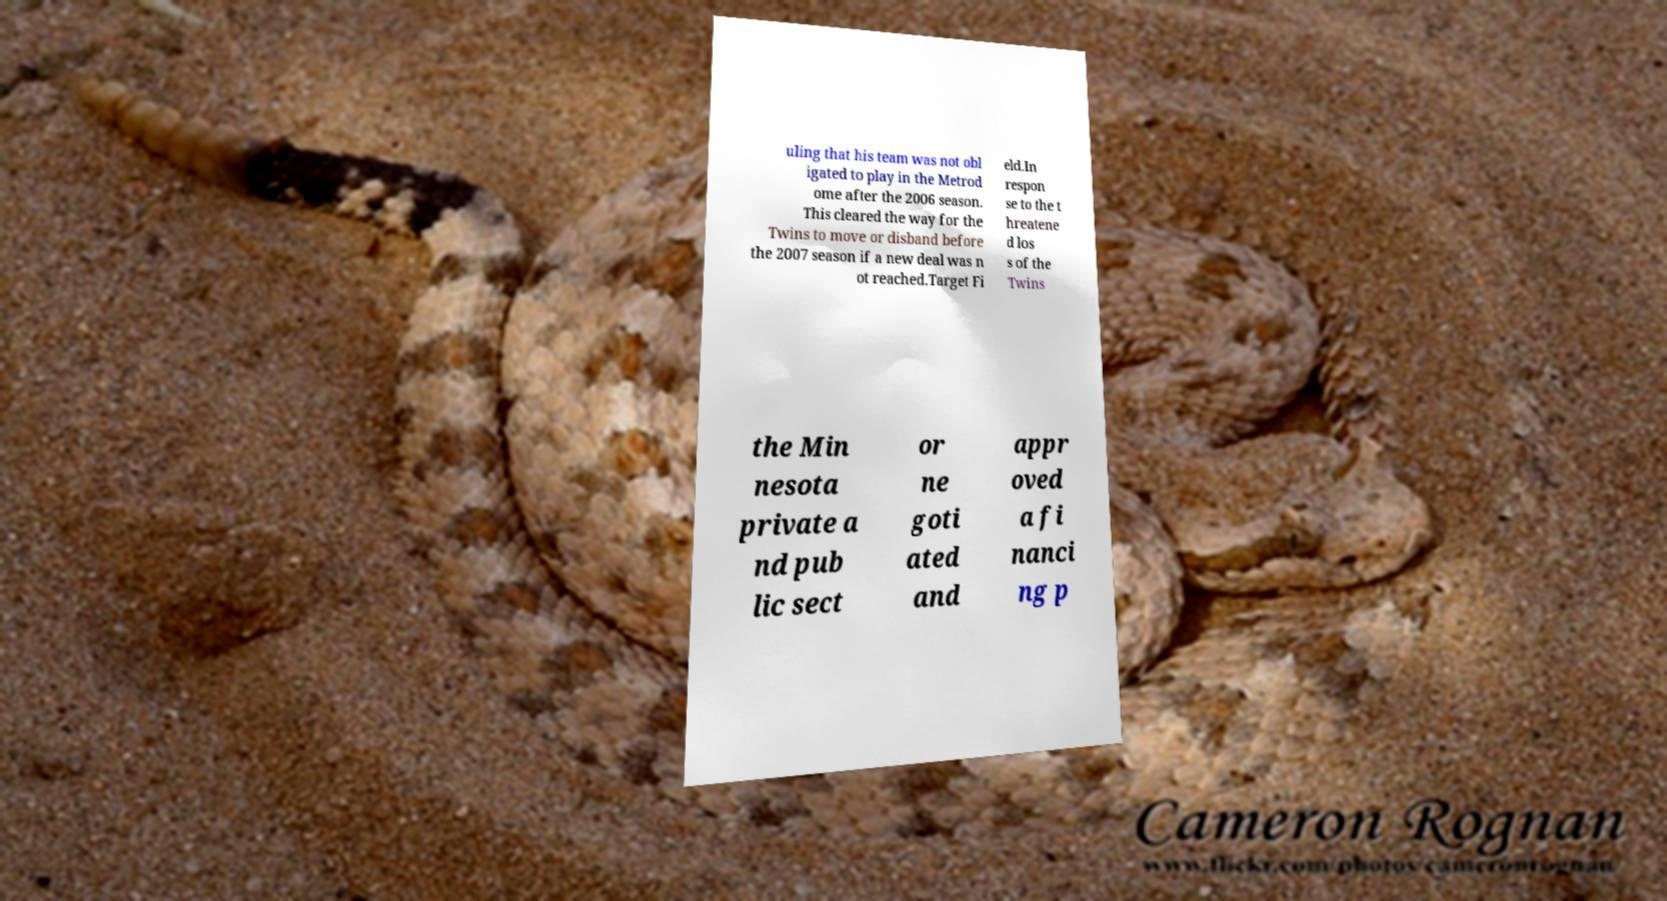I need the written content from this picture converted into text. Can you do that? uling that his team was not obl igated to play in the Metrod ome after the 2006 season. This cleared the way for the Twins to move or disband before the 2007 season if a new deal was n ot reached.Target Fi eld.In respon se to the t hreatene d los s of the Twins the Min nesota private a nd pub lic sect or ne goti ated and appr oved a fi nanci ng p 